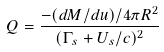<formula> <loc_0><loc_0><loc_500><loc_500>Q = \frac { - ( d M / d u ) / 4 \pi R ^ { 2 } } { ( \Gamma _ { s } + U _ { s } / c ) ^ { 2 } }</formula> 